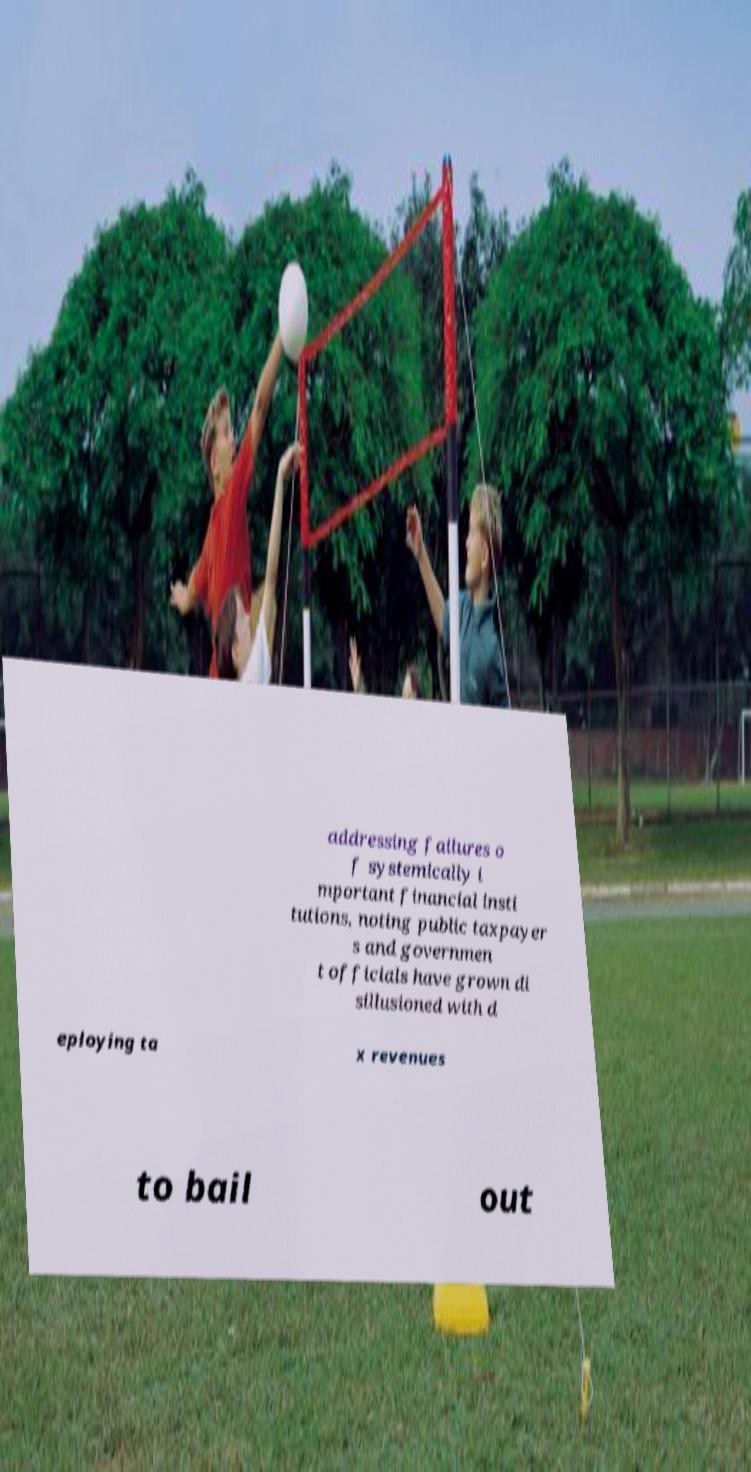Could you assist in decoding the text presented in this image and type it out clearly? addressing failures o f systemically i mportant financial insti tutions, noting public taxpayer s and governmen t officials have grown di sillusioned with d eploying ta x revenues to bail out 